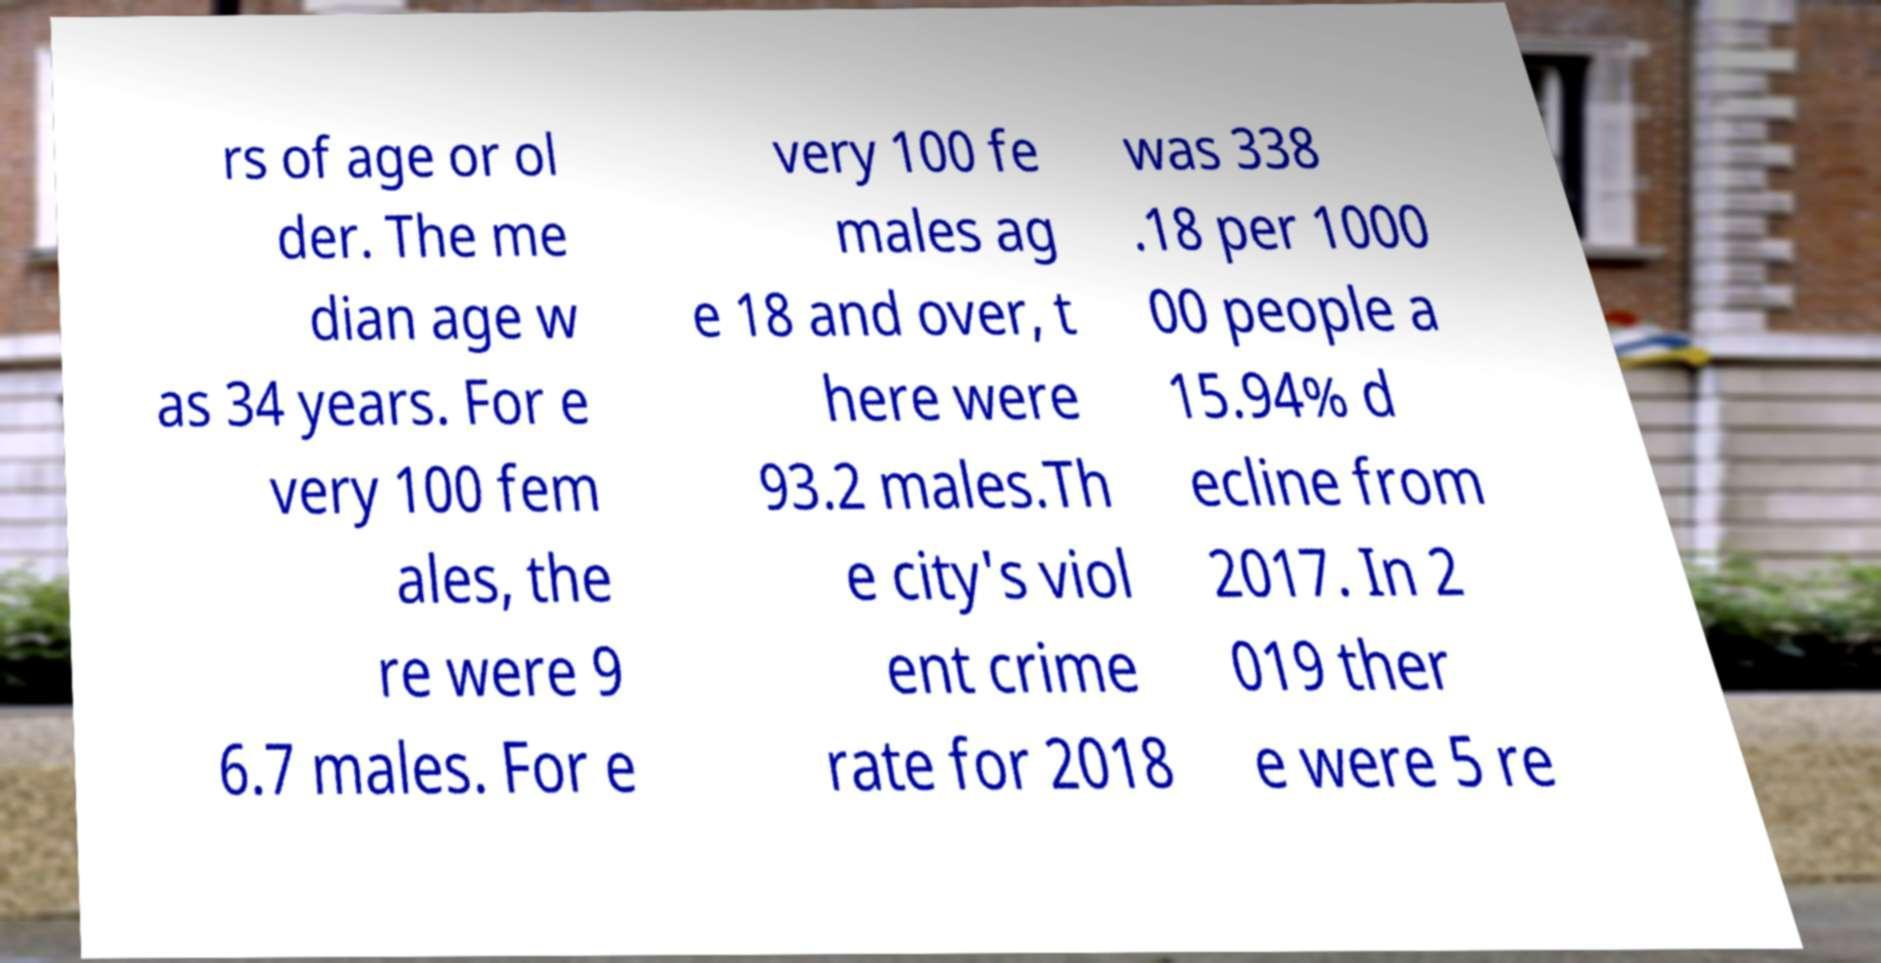There's text embedded in this image that I need extracted. Can you transcribe it verbatim? rs of age or ol der. The me dian age w as 34 years. For e very 100 fem ales, the re were 9 6.7 males. For e very 100 fe males ag e 18 and over, t here were 93.2 males.Th e city's viol ent crime rate for 2018 was 338 .18 per 1000 00 people a 15.94% d ecline from 2017. In 2 019 ther e were 5 re 